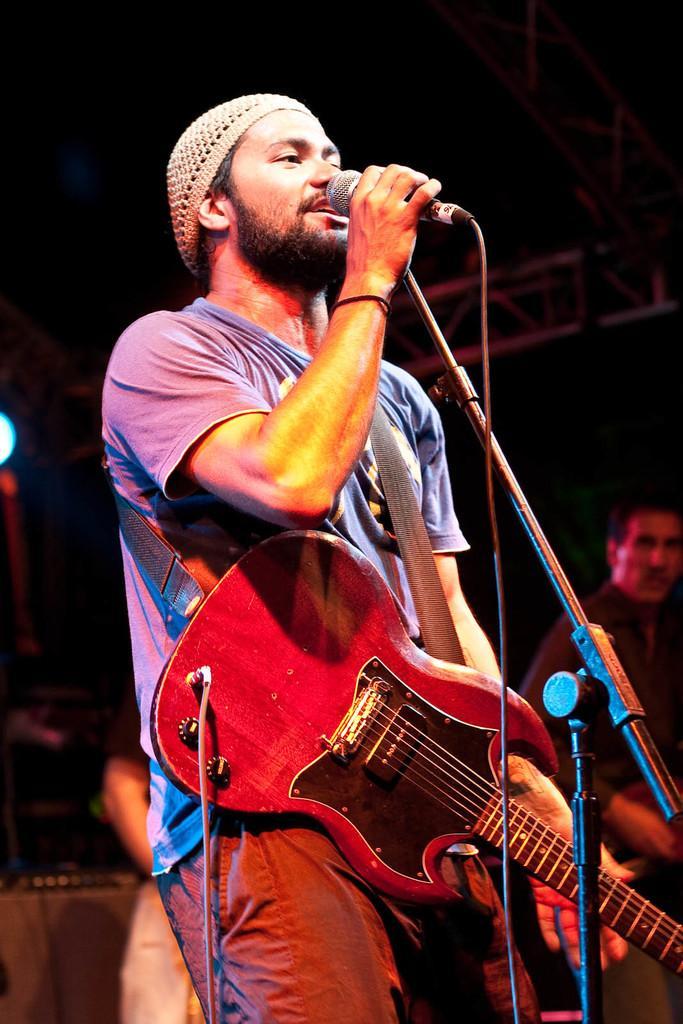Could you give a brief overview of what you see in this image? This man wore guitar, holding mic and singing. Far this man is also standing. 